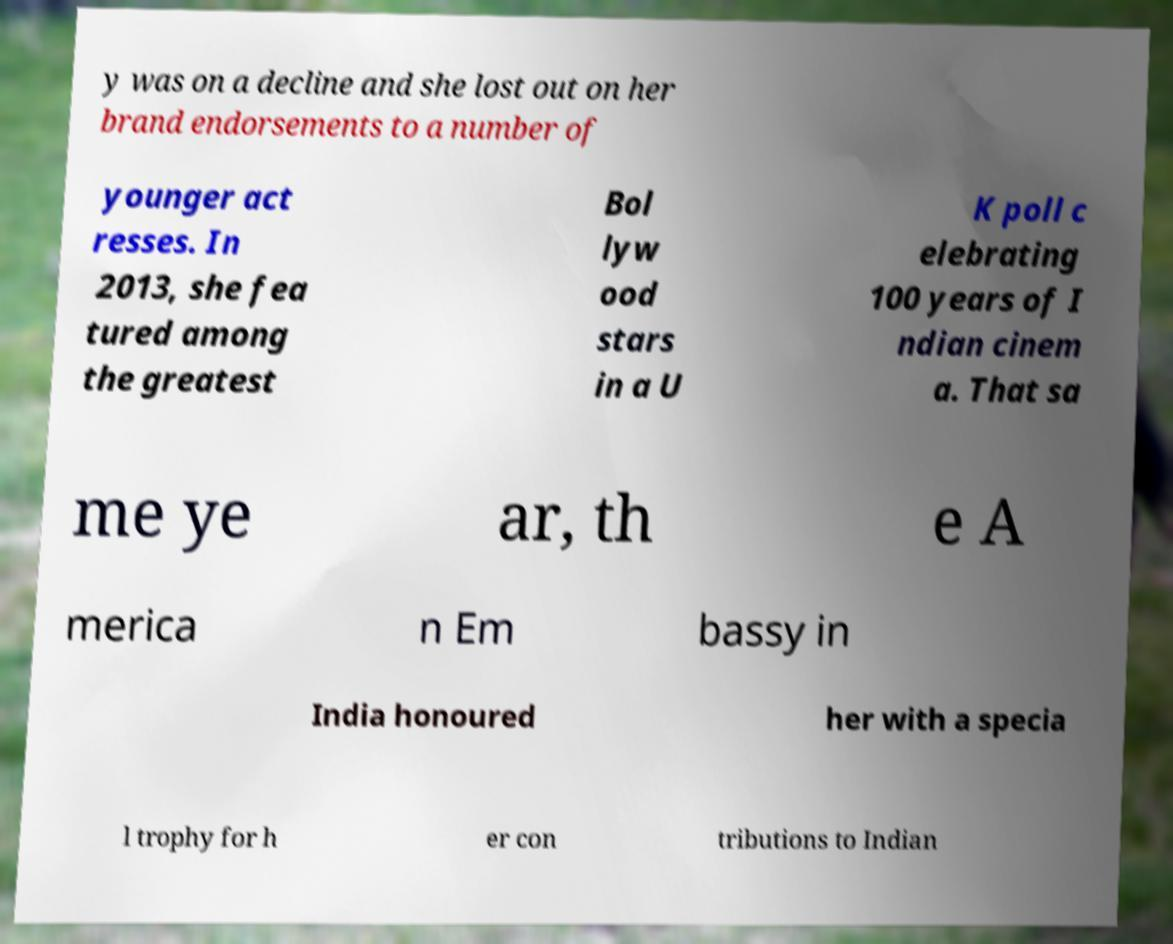Please identify and transcribe the text found in this image. y was on a decline and she lost out on her brand endorsements to a number of younger act resses. In 2013, she fea tured among the greatest Bol lyw ood stars in a U K poll c elebrating 100 years of I ndian cinem a. That sa me ye ar, th e A merica n Em bassy in India honoured her with a specia l trophy for h er con tributions to Indian 